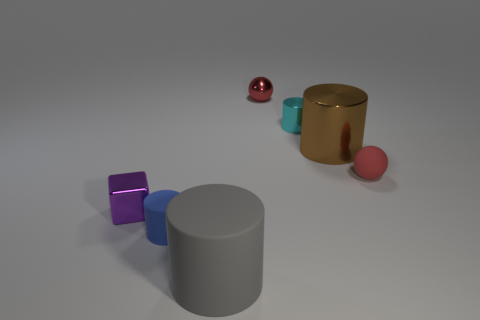Add 2 small shiny balls. How many objects exist? 9 Subtract all cylinders. How many objects are left? 3 Add 3 tiny red things. How many tiny red things exist? 5 Subtract 0 yellow balls. How many objects are left? 7 Subtract all gray metal balls. Subtract all rubber cylinders. How many objects are left? 5 Add 5 tiny red things. How many tiny red things are left? 7 